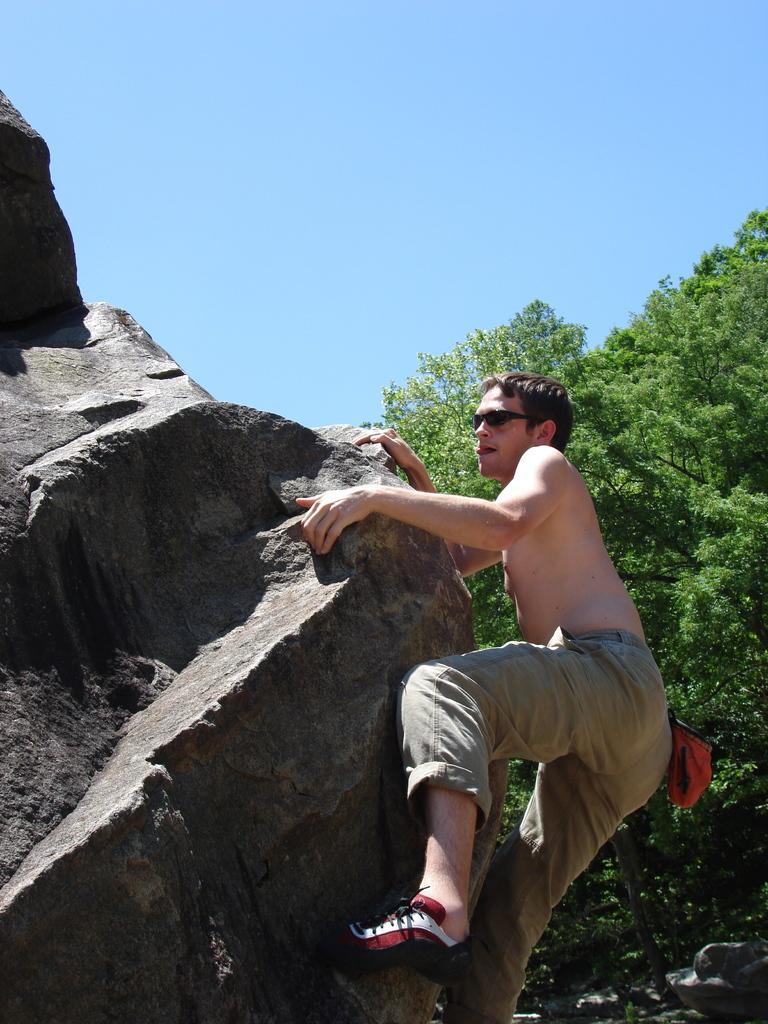How would you summarize this image in a sentence or two? There is a person climbing the rock. He is wearing a pant and shoes. We can observe a big rock here. In the background there is tree and sky. 